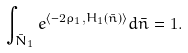<formula> <loc_0><loc_0><loc_500><loc_500>\int _ { \bar { N } _ { 1 } } e ^ { \langle - 2 \rho _ { 1 } , H _ { 1 } ( \bar { n } ) \rangle } d \bar { n } = 1 .</formula> 